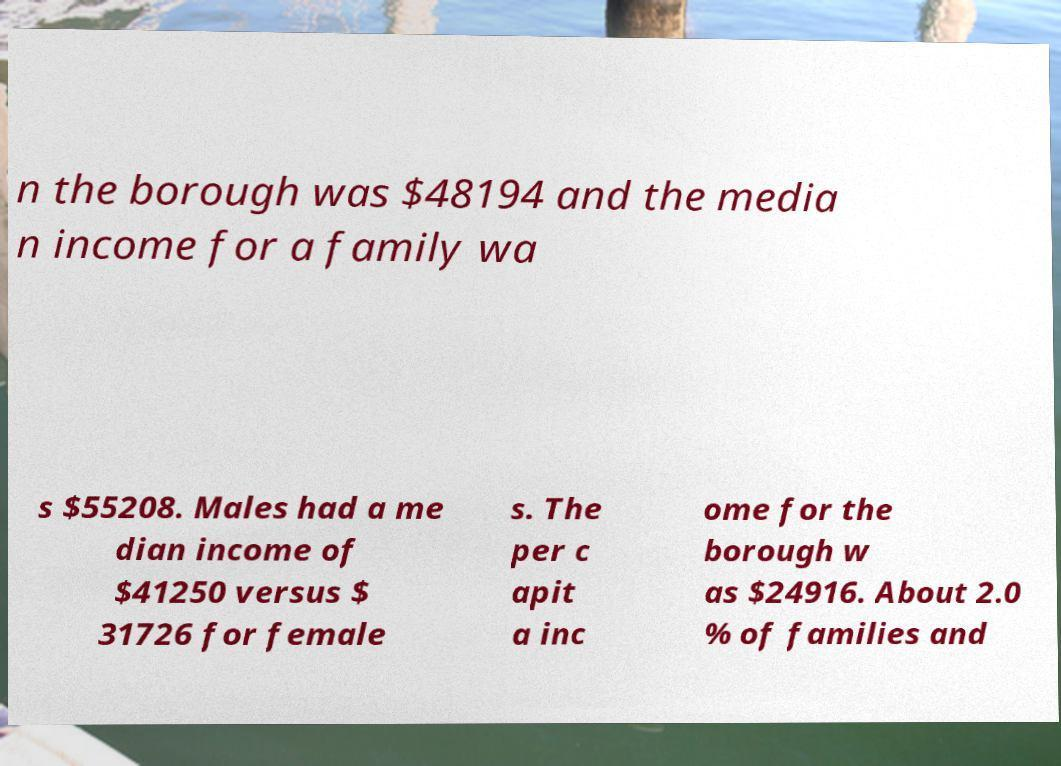Please identify and transcribe the text found in this image. n the borough was $48194 and the media n income for a family wa s $55208. Males had a me dian income of $41250 versus $ 31726 for female s. The per c apit a inc ome for the borough w as $24916. About 2.0 % of families and 